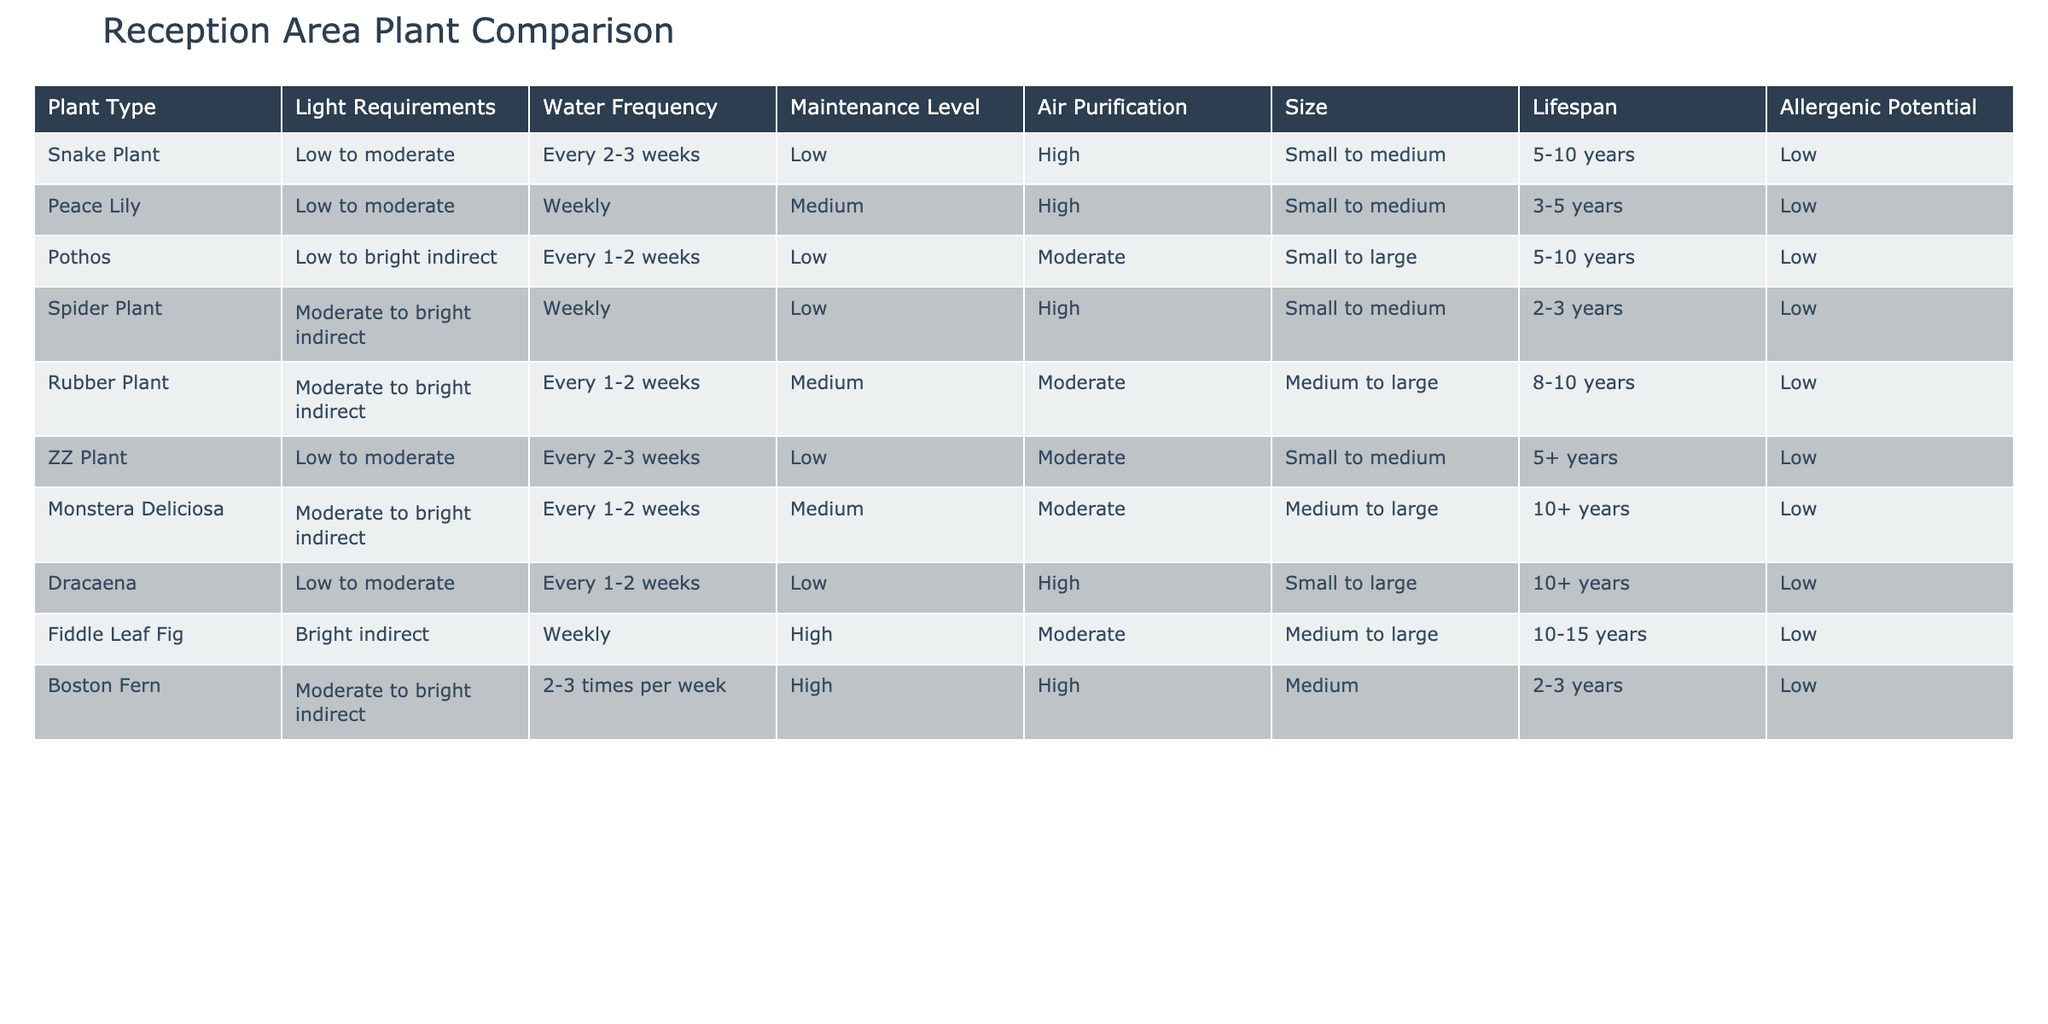What are the light requirements for the Fiddle Leaf Fig? The table shows that the Fiddle Leaf Fig has bright indirect light requirements. Thus, this is the specific information extracted from the row corresponding to the Fiddle Leaf Fig.
Answer: Bright indirect How often does the Spider Plant need to be watered? According to the table, the Spider Plant requires watering weekly. This information can be directly found in the row corresponding to the Spider Plant.
Answer: Weekly Which plant has the highest maintenance level? The Fiddle Leaf Fig is listed as having a high maintenance level, which is higher than any other plant in the table. This observation is made by comparing the maintenance levels across all listed plants.
Answer: Fiddle Leaf Fig Which plants require watering every 1-2 weeks? The plants that require watering every 1-2 weeks are Pothos, Rubber Plant, Monstera Deliciosa, and Dracaena. This is determined by filtering the watering frequency column for the value "Every 1-2 weeks."
Answer: Pothos, Rubber Plant, Monstera Deliciosa, Dracaena Is the Snake Plant allergenic? The table indicates that the Snake Plant has a low allergenic potential. Since it does not display any characteristics that would cause allergy, the answer is based on the specific entry related to the Snake Plant.
Answer: No Which plant has the longest lifespan? The Monstera Deliciosa has the longest lifespan of over 10 years, as indicated in the lifespan column. This conclusion is drawn by comparing the lifespan values of all plants listed in the table.
Answer: Monstera Deliciosa From the listed plants, how many have high air purification capabilities? The plants that have high air purification capabilities are Snake Plant, Peace Lily, Spider Plant, Boston Fern. This was determined by counting the plants with "High" in the air purification column. The total count is four.
Answer: Four Which plants have low maintenance levels and require low light? The plants with low maintenance levels that also require low light are Snake Plant, Pothos, and ZZ Plant. This is concluded by filtering the table for plants that fit both criteria simultaneously.
Answer: Snake Plant, Pothos, ZZ Plant Which plant has the smallest size? The Snake Plant and the Peace Lily are both categorized as small to medium, making them the plants with the smallest size. This can be inferred from the size column and reviewing the row entries for size.
Answer: Snake Plant and Peace Lily 